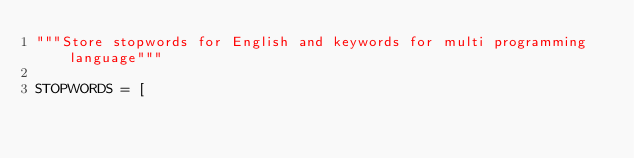<code> <loc_0><loc_0><loc_500><loc_500><_Python_>"""Store stopwords for English and keywords for multi programming language"""

STOPWORDS = [</code> 